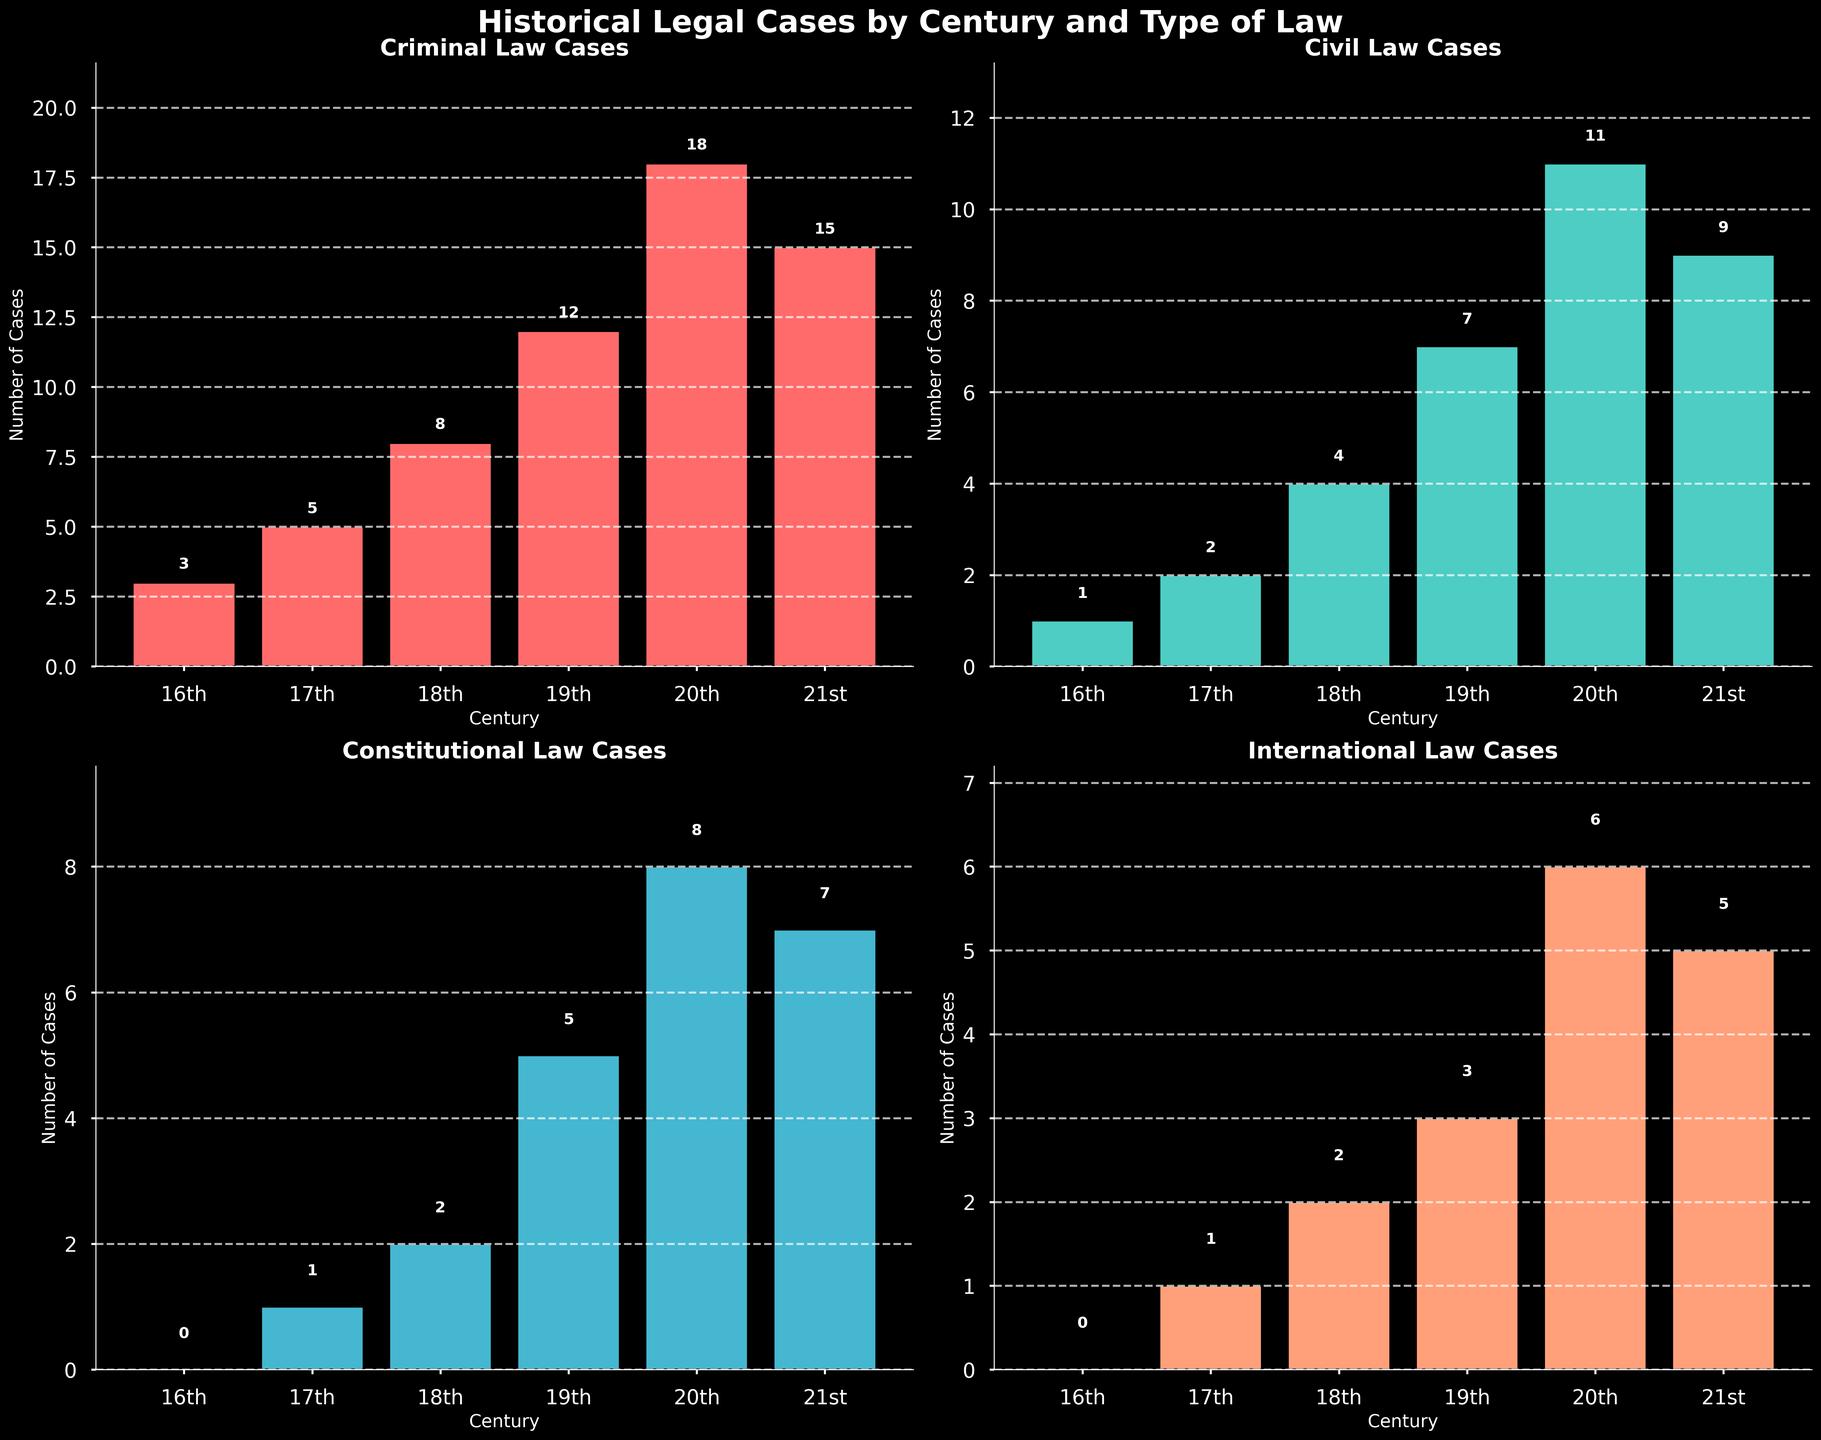what is the title of the figure? The title is located at the top of the figure in bold text.
Answer: Historical Legal Cases by Century and Type of Law What is the color used for "Civil Law Cases"? The color for each category is distinct and can be identified from the bar colors.
Answer: Light Green (Cyan-like) Which century has the highest number of Constitutional law cases? Look at the Constitutional subplot and compare the heights of the bars. The tallest bar indicates the century with the highest number.
Answer: 20th Century How many criminal law cases were there in the 16th century? Check the Criminal subplot and locate the bar for the 16th century. The height and the number above the bar show the count.
Answer: 3 What is the difference in the number of Civil law cases between the 18th century and the 19th century? Subtract the number of Civil law cases in the 18th century from those in the 19th century by comparing the bars in the Civil subplot.
Answer: 3 What is the total number of International law cases across all centuries? Add the heights/numbers of all bars in the International law subplot: 0+1+2+3+6=5+6=11
Answer: 17 In which century did Constitutional law cases first appear? Look at the Constitutional law cases subplot and check the first century with a bar greater than zero.
Answer: 17th Century Which type of law had the highest total cases in the 20th century? Check the heights/numbers of the bars for each type of law in the 20th century and identify the highest one.
Answer: Criminal Law Compare the growth rate of Criminal law cases from the 17th century to the 18th century with that of Civil law cases over the same period. Which grew more? Calculate the difference for Criminal law (8-5)/5 and for Civil law (4-2)/2. Compare the two growth rates.
Answer: Civil Law Which type of law shows a decreasing trend in the number of cases from the 20th century to the 21st century? Check which subplot has a bar height lower in the 21st century than in the 20th century.
Answer: Criminal Law 